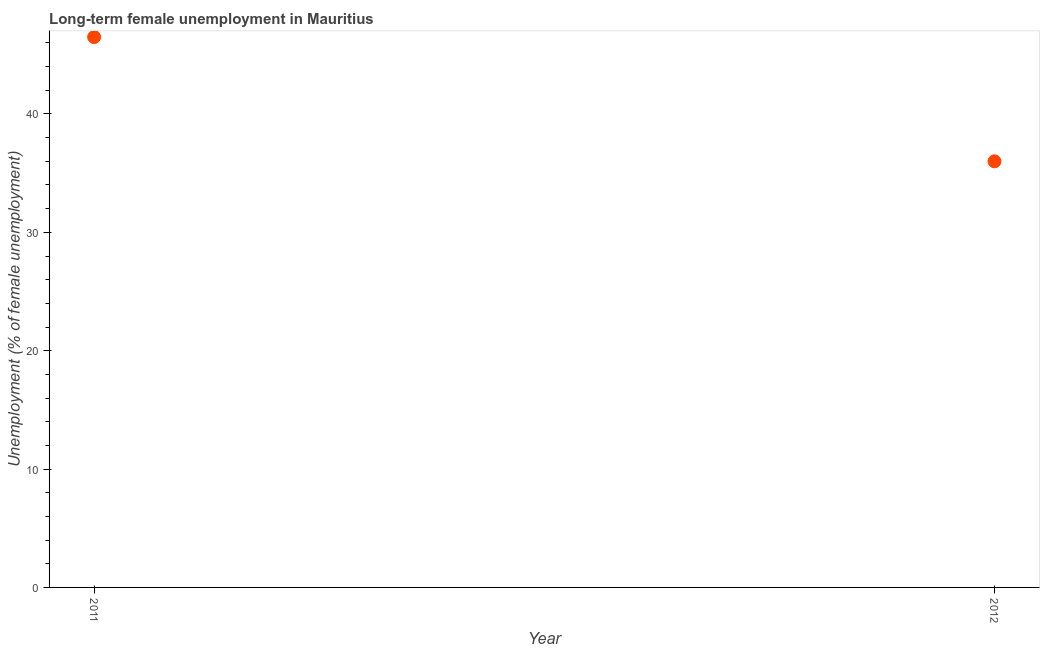What is the long-term female unemployment in 2011?
Your answer should be compact. 46.5. Across all years, what is the maximum long-term female unemployment?
Make the answer very short. 46.5. Across all years, what is the minimum long-term female unemployment?
Your answer should be compact. 36. What is the sum of the long-term female unemployment?
Keep it short and to the point. 82.5. What is the average long-term female unemployment per year?
Provide a succinct answer. 41.25. What is the median long-term female unemployment?
Ensure brevity in your answer.  41.25. In how many years, is the long-term female unemployment greater than 8 %?
Provide a succinct answer. 2. Do a majority of the years between 2011 and 2012 (inclusive) have long-term female unemployment greater than 34 %?
Keep it short and to the point. Yes. What is the ratio of the long-term female unemployment in 2011 to that in 2012?
Your response must be concise. 1.29. Is the long-term female unemployment in 2011 less than that in 2012?
Provide a succinct answer. No. In how many years, is the long-term female unemployment greater than the average long-term female unemployment taken over all years?
Your response must be concise. 1. Are the values on the major ticks of Y-axis written in scientific E-notation?
Offer a very short reply. No. Does the graph contain any zero values?
Ensure brevity in your answer.  No. Does the graph contain grids?
Ensure brevity in your answer.  No. What is the title of the graph?
Give a very brief answer. Long-term female unemployment in Mauritius. What is the label or title of the X-axis?
Keep it short and to the point. Year. What is the label or title of the Y-axis?
Offer a terse response. Unemployment (% of female unemployment). What is the Unemployment (% of female unemployment) in 2011?
Make the answer very short. 46.5. What is the ratio of the Unemployment (% of female unemployment) in 2011 to that in 2012?
Make the answer very short. 1.29. 